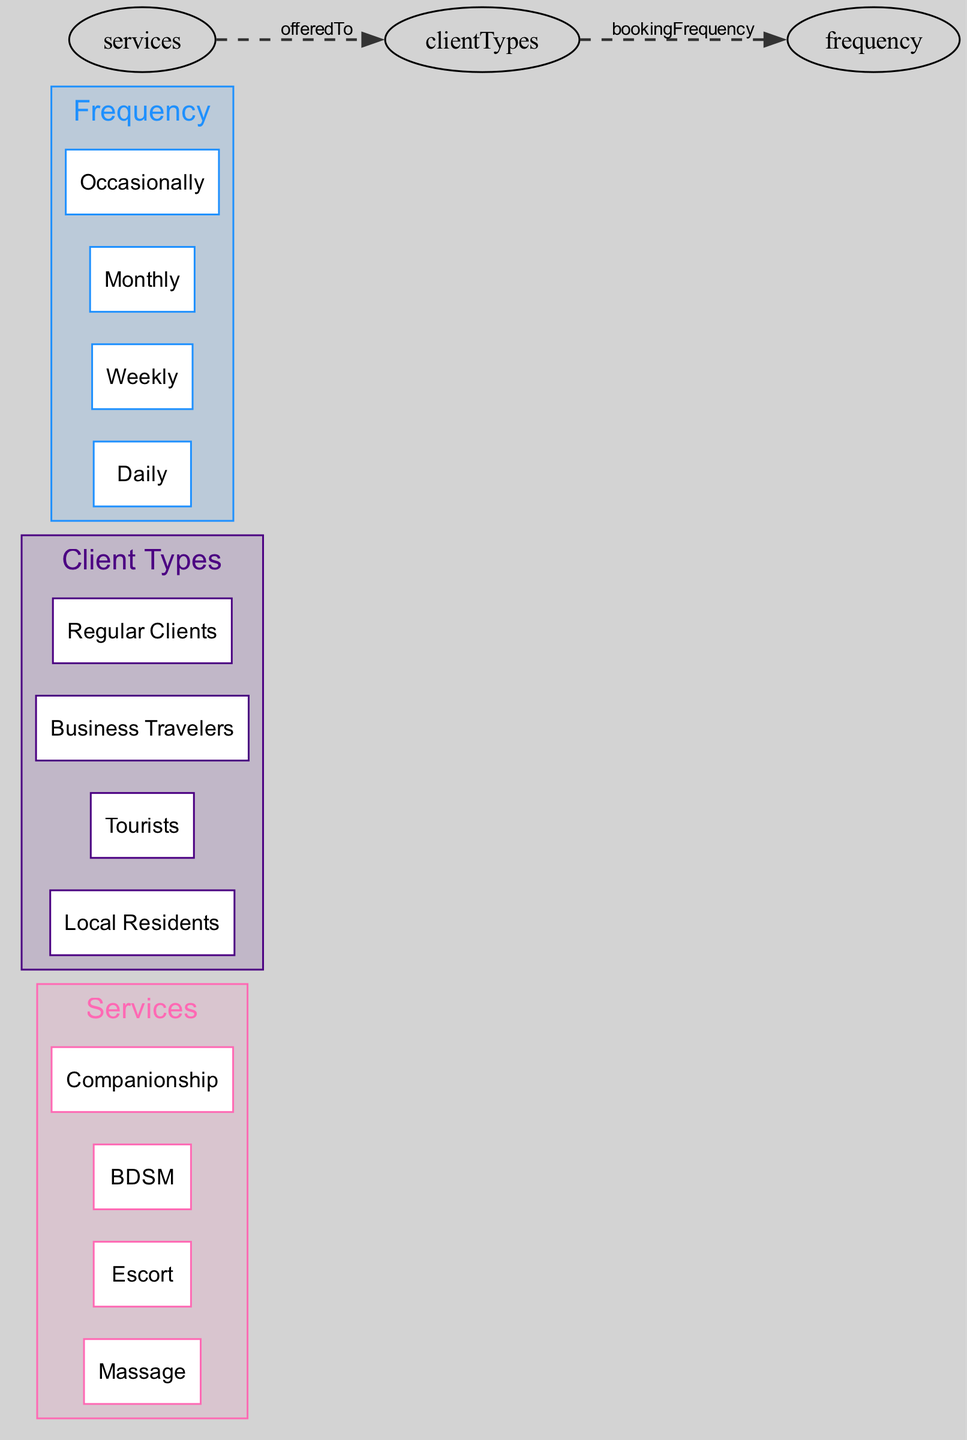What is the title of the diagram? The title is explicitly stated at the top of the diagram, which is "Client Preferences and Frequency Heatmap."
Answer: Client Preferences and Frequency Heatmap How many types of services are listed in the diagram? The "Services" node contains four subnodes: Massage, Escort, BDSM, and Companionship. Counting these gives a total of four services.
Answer: 4 What is the relationship between services and client types? The connection labeled "offeredTo" indicates that services are provided to client types, establishing a direct relationship between these two categories.
Answer: offeredTo Which client type is associated with the highest booking frequency? By analyzing the "Client Types" and "Frequency" nodes, it can be inferred that Regular Clients are likely to have a higher frequency of booking compared to other types, like tourists or local residents.
Answer: Regular Clients How many edges are present in the diagram? There are two relationships (edges) defined in the diagram, which are the connection from services to client types and from client types to frequency.
Answer: 2 Name one type of service that tourists might prefer. Since all services are offered to every client type according to the "offeredTo" relationship, any listed service can be preferred by tourists, such as Escort or Massage.
Answer: Escort What is the frequency classification associated with companionship? The frequency classification would depend on client engagement trends, but assuming from the booking nature, it may be Occasional or Weekly as companionship often isn't a daily requirement.
Answer: Occasionally What color represents the client types in the diagram? The specific colors are assigned within the diagram, and from the defined color scheme, Client Types are represented by the second color in the sequence, which is purple (#4B0082).
Answer: Purple Which category has more options: services or frequency? Counting the subnodes shows that "Services" has four options: Massage, Escort, BDSM, and Companionship, while "Frequency" has four options: Daily, Weekly, Monthly, and Occasionally. Both categories have the same number of options.
Answer: Equal What does the frequency node represent? The "Frequency" node captures how often clients tend to book services, detailing categories like daily, weekly, monthly, and occasionally.
Answer: Booking frequency 